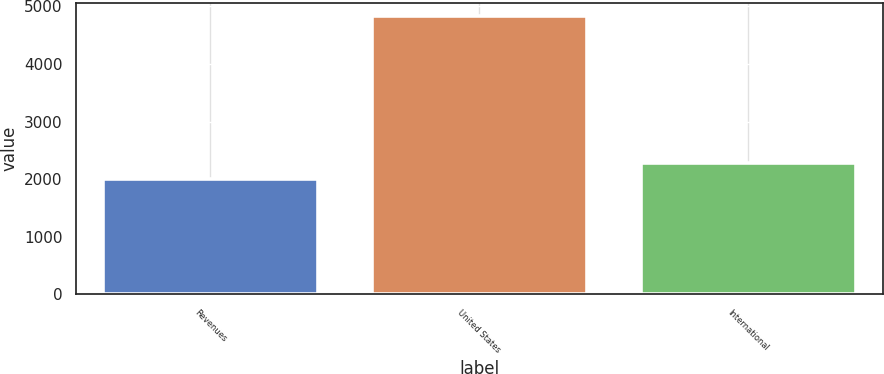Convert chart. <chart><loc_0><loc_0><loc_500><loc_500><bar_chart><fcel>Revenues<fcel>United States<fcel>International<nl><fcel>2001<fcel>4827<fcel>2283.6<nl></chart> 